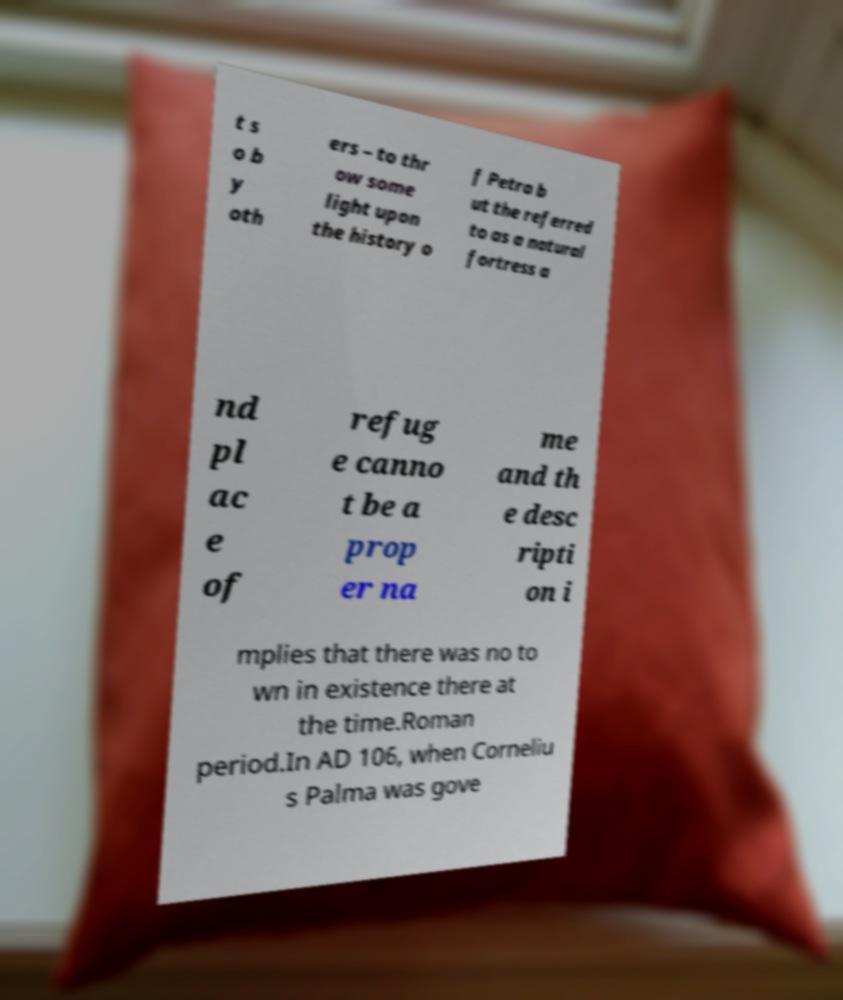Could you assist in decoding the text presented in this image and type it out clearly? t s o b y oth ers – to thr ow some light upon the history o f Petra b ut the referred to as a natural fortress a nd pl ac e of refug e canno t be a prop er na me and th e desc ripti on i mplies that there was no to wn in existence there at the time.Roman period.In AD 106, when Corneliu s Palma was gove 